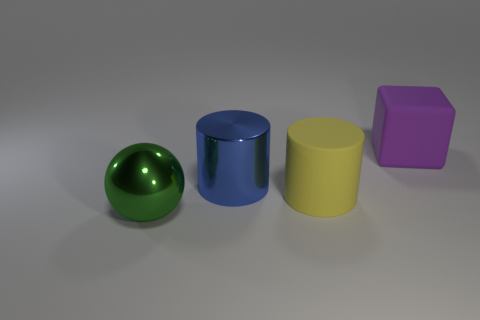There is a metallic object that is in front of the blue metal object; is it the same size as the large yellow object?
Your answer should be compact. Yes. There is a big blue thing that is the same shape as the yellow object; what is its material?
Keep it short and to the point. Metal. Is the shape of the big blue shiny object the same as the purple matte object?
Offer a very short reply. No. There is a cylinder behind the big yellow object; how many big green things are in front of it?
Give a very brief answer. 1. The thing that is made of the same material as the green sphere is what shape?
Your answer should be very brief. Cylinder. What number of cyan objects are either tiny cylinders or large rubber objects?
Provide a short and direct response. 0. Are there any rubber blocks behind the cylinder in front of the large metallic object that is behind the large green ball?
Make the answer very short. Yes. Are there fewer tiny matte cubes than yellow rubber things?
Provide a succinct answer. Yes. There is a large matte object on the right side of the yellow cylinder; does it have the same shape as the yellow thing?
Provide a succinct answer. No. Is there a purple matte block?
Your answer should be very brief. Yes. 